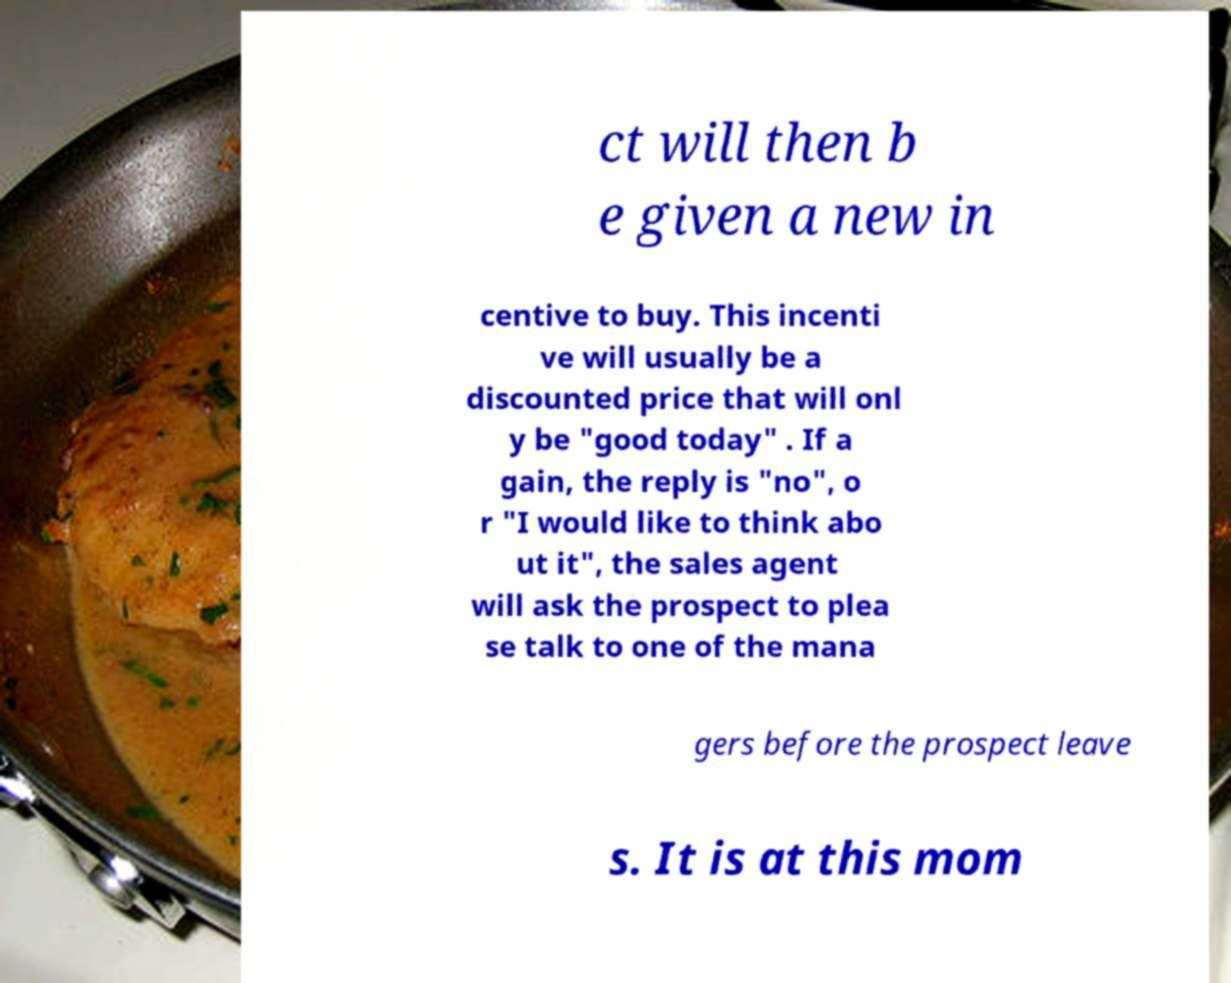Can you read and provide the text displayed in the image?This photo seems to have some interesting text. Can you extract and type it out for me? ct will then b e given a new in centive to buy. This incenti ve will usually be a discounted price that will onl y be "good today" . If a gain, the reply is "no", o r "I would like to think abo ut it", the sales agent will ask the prospect to plea se talk to one of the mana gers before the prospect leave s. It is at this mom 